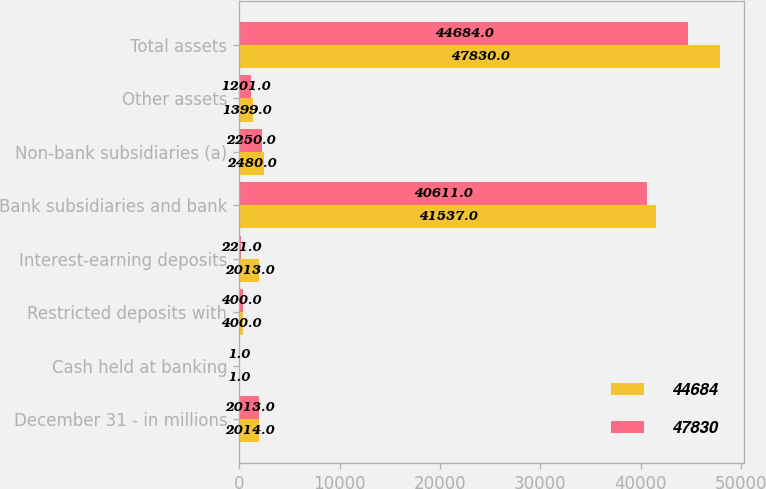Convert chart. <chart><loc_0><loc_0><loc_500><loc_500><stacked_bar_chart><ecel><fcel>December 31 - in millions<fcel>Cash held at banking<fcel>Restricted deposits with<fcel>Interest-earning deposits<fcel>Bank subsidiaries and bank<fcel>Non-bank subsidiaries (a)<fcel>Other assets<fcel>Total assets<nl><fcel>44684<fcel>2014<fcel>1<fcel>400<fcel>2013<fcel>41537<fcel>2480<fcel>1399<fcel>47830<nl><fcel>47830<fcel>2013<fcel>1<fcel>400<fcel>221<fcel>40611<fcel>2250<fcel>1201<fcel>44684<nl></chart> 